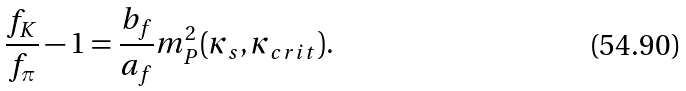<formula> <loc_0><loc_0><loc_500><loc_500>\frac { f _ { K } } { f _ { \pi } } - 1 = \frac { b _ { f } } { a _ { f } } m _ { P } ^ { 2 } ( \kappa _ { s } , \kappa _ { c r i t } ) .</formula> 